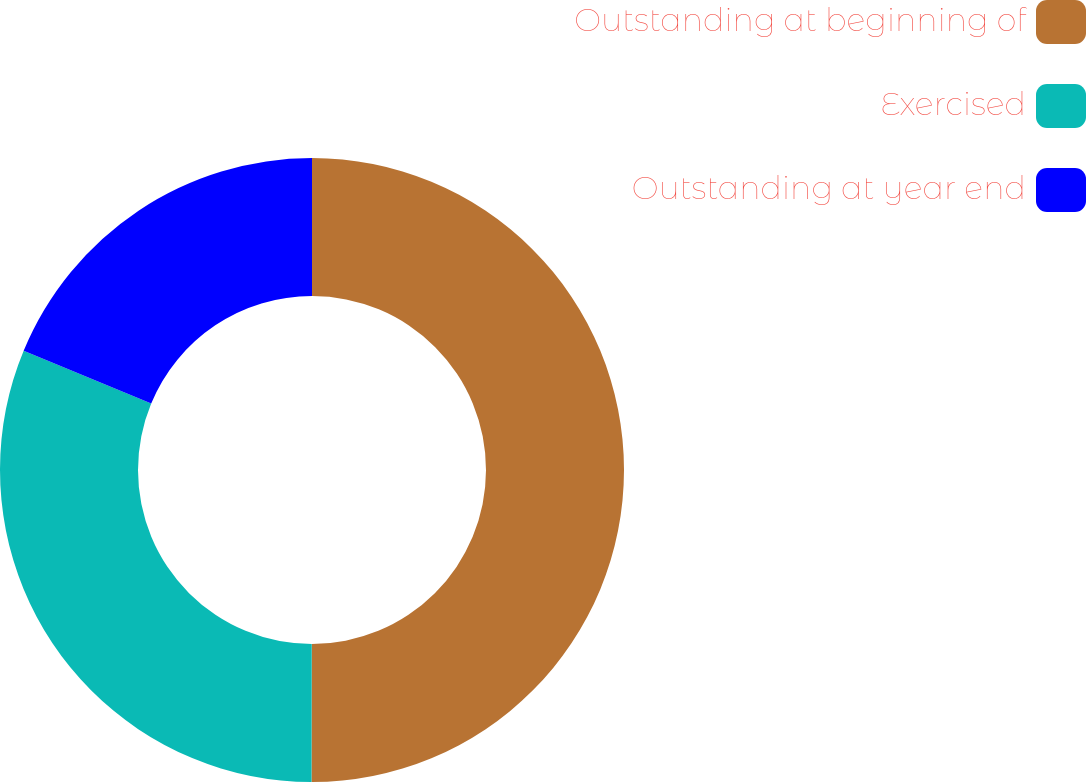<chart> <loc_0><loc_0><loc_500><loc_500><pie_chart><fcel>Outstanding at beginning of<fcel>Exercised<fcel>Outstanding at year end<nl><fcel>50.02%<fcel>31.21%<fcel>18.76%<nl></chart> 